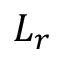<formula> <loc_0><loc_0><loc_500><loc_500>L _ { r }</formula> 